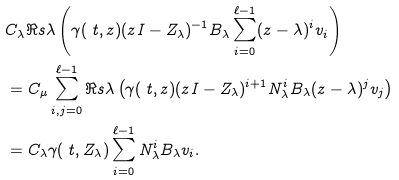<formula> <loc_0><loc_0><loc_500><loc_500>& C _ { \lambda } \Re s { \lambda } \left ( \gamma ( \ t , z ) ( z I - Z _ { \lambda } ) ^ { - 1 } B _ { \lambda } \sum _ { i = 0 } ^ { \ell - 1 } ( z - \lambda ) ^ { i } v _ { i } \right ) \\ & = C _ { \mu } \sum _ { i , j = 0 } ^ { \ell - 1 } \Re s { \lambda } \left ( \gamma ( \ t , z ) ( z I - Z _ { \lambda } ) ^ { i + 1 } N _ { \lambda } ^ { i } B _ { \lambda } ( z - \lambda ) ^ { j } v _ { j } \right ) \\ & = C _ { \lambda } \gamma ( \ t , Z _ { \lambda } ) \sum _ { i = 0 } ^ { \ell - 1 } N _ { \lambda } ^ { i } B _ { \lambda } v _ { i } .</formula> 